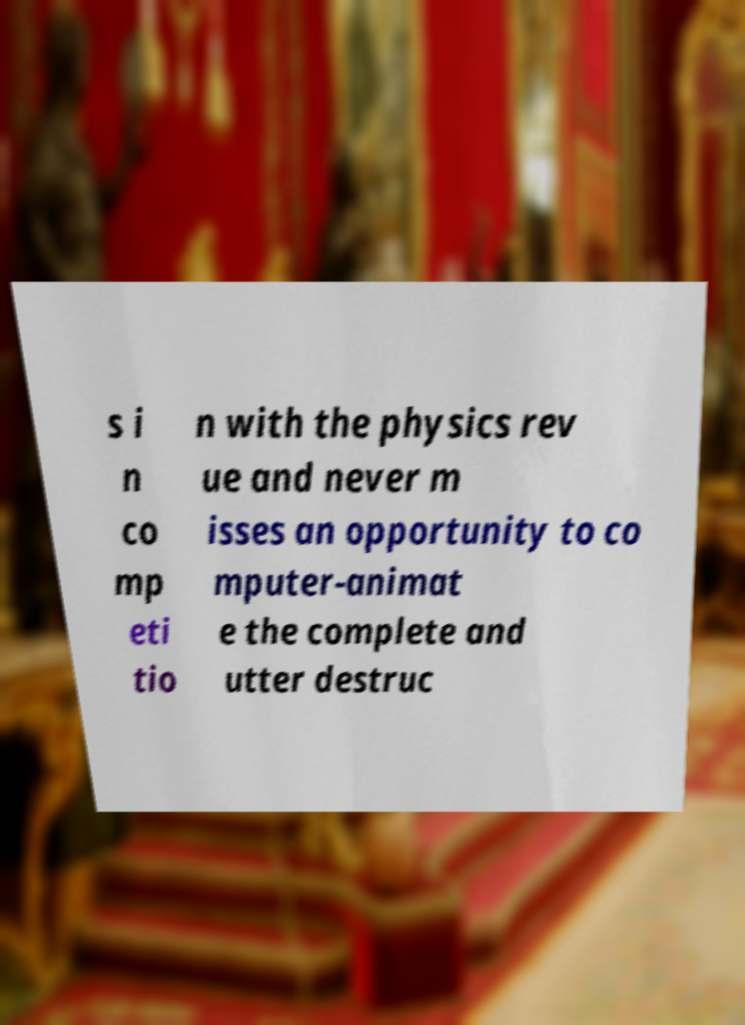What messages or text are displayed in this image? I need them in a readable, typed format. s i n co mp eti tio n with the physics rev ue and never m isses an opportunity to co mputer-animat e the complete and utter destruc 